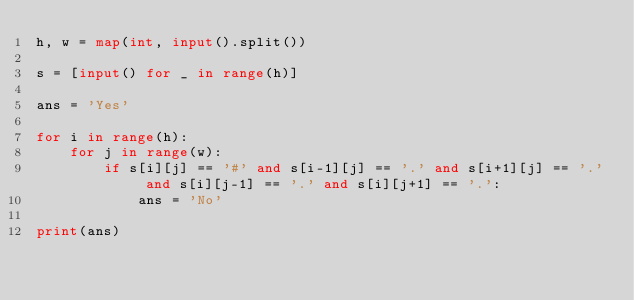Convert code to text. <code><loc_0><loc_0><loc_500><loc_500><_Python_>h, w = map(int, input().split())

s = [input() for _ in range(h)]

ans = 'Yes'

for i in range(h):
    for j in range(w):
        if s[i][j] == '#' and s[i-1][j] == '.' and s[i+1][j] == '.' and s[i][j-1] == '.' and s[i][j+1] == '.':
            ans = 'No'

print(ans)</code> 